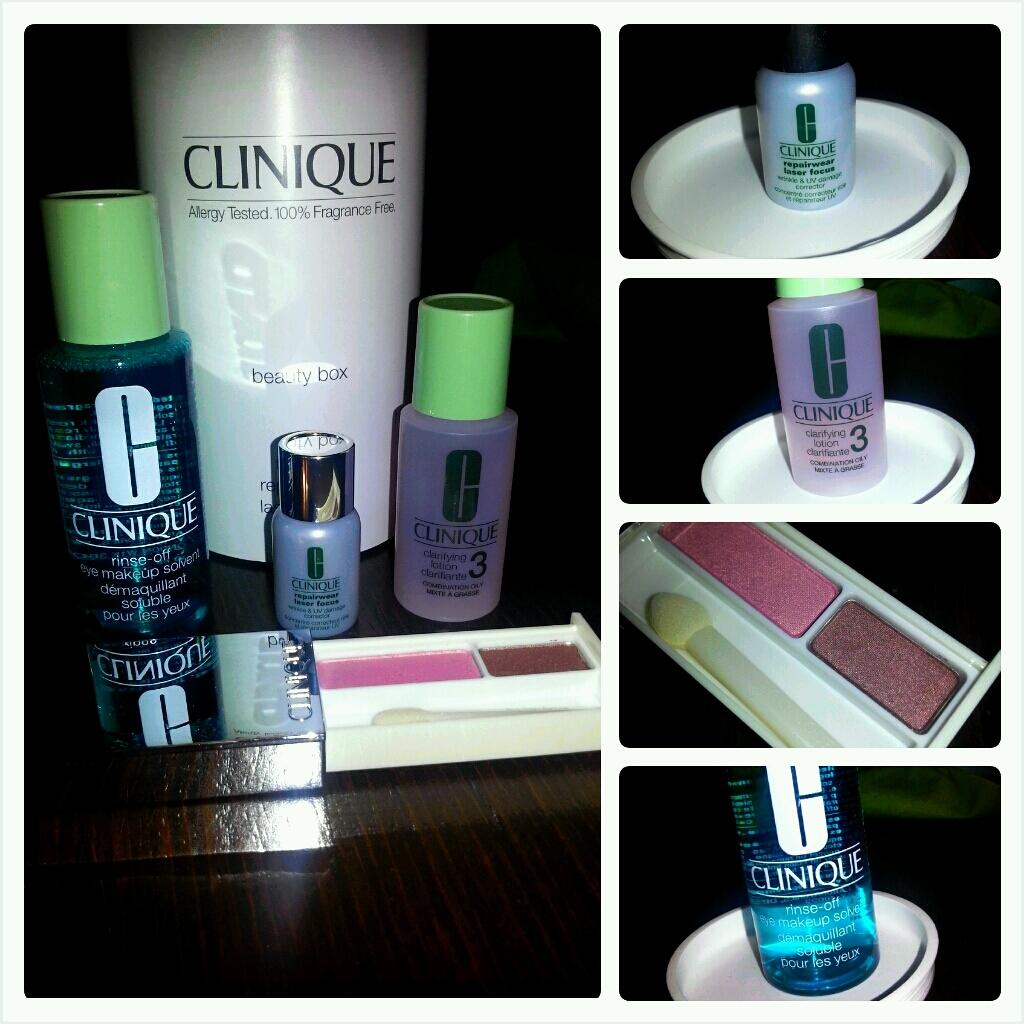<image>
Create a compact narrative representing the image presented. Several bottles of makeup of diffeerent kinds with the name Clinique on the biggest one. 